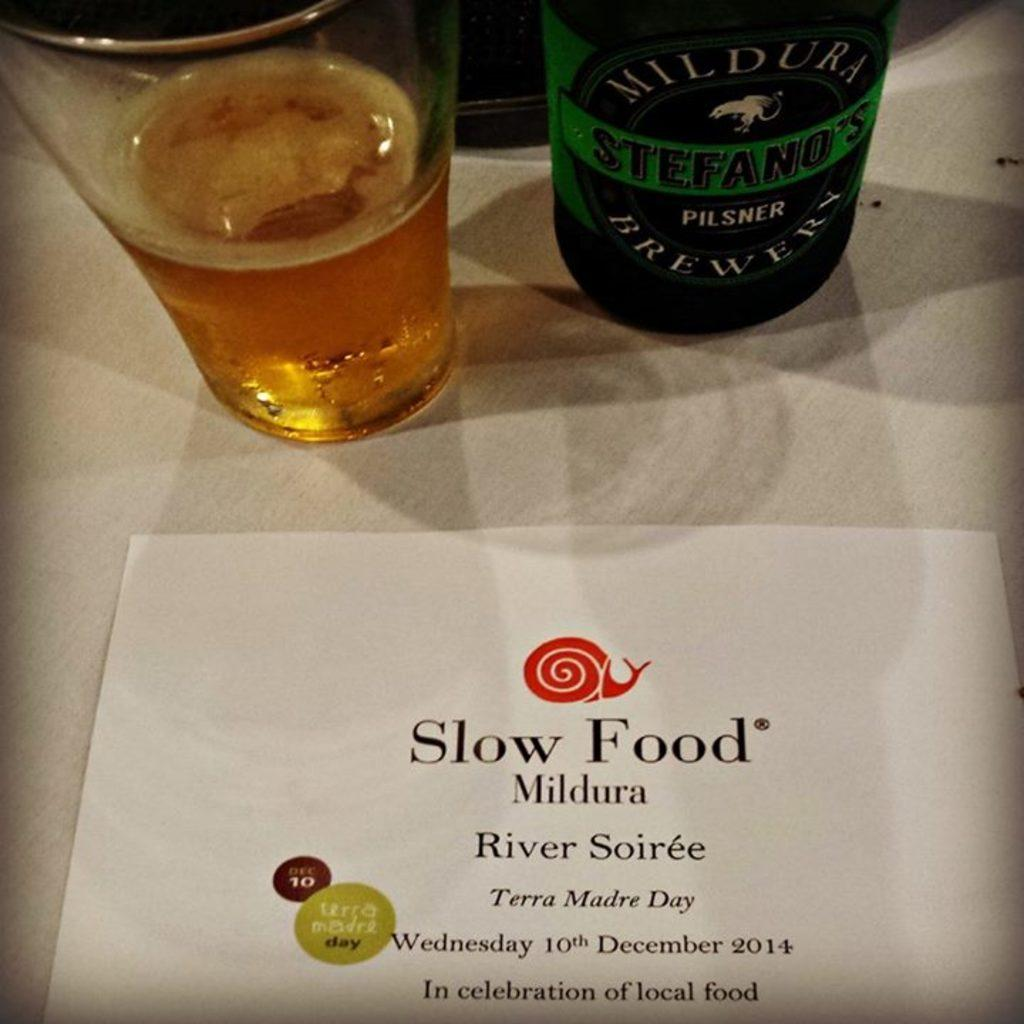<image>
Present a compact description of the photo's key features. A bottle of beer next to a glass of beer with a paper in front that states Slow Food Mildura. 